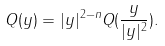<formula> <loc_0><loc_0><loc_500><loc_500>Q ( y ) = | y | ^ { 2 - n } Q ( \frac { y } { | y | ^ { 2 } } ) .</formula> 